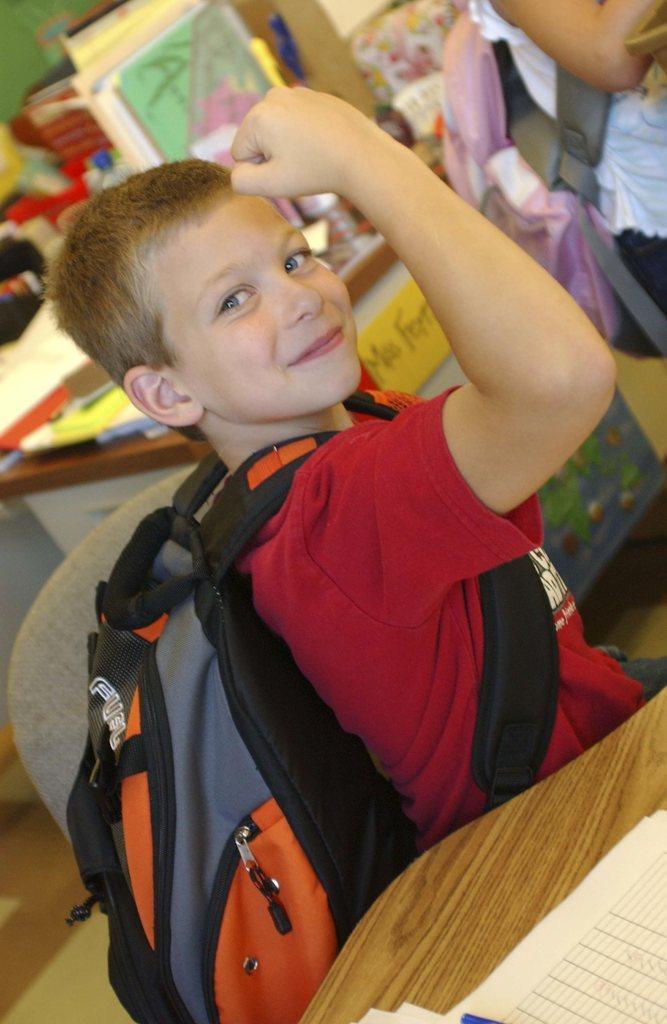In one or two sentences, can you explain what this image depicts? In this image I can see a boy wearing red t shirt and bag is sitting on a chair. I can see a table and few papers on it. In the background I can see another table with few objects on it and a person wearing a bag. 